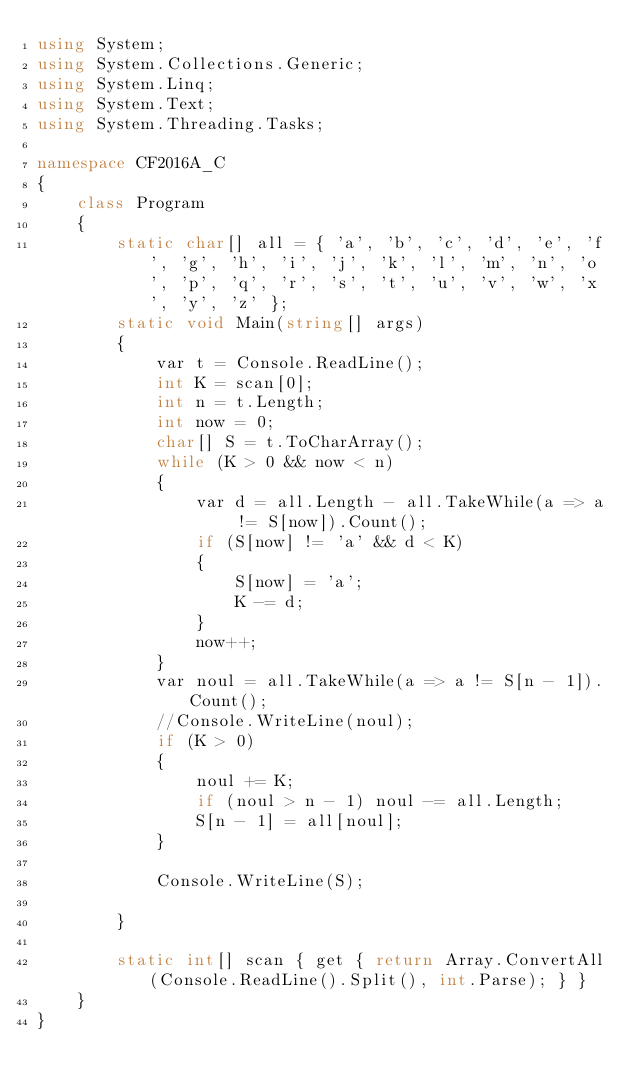<code> <loc_0><loc_0><loc_500><loc_500><_C#_>using System;
using System.Collections.Generic;
using System.Linq;
using System.Text;
using System.Threading.Tasks;

namespace CF2016A_C
{
    class Program
    {
        static char[] all = { 'a', 'b', 'c', 'd', 'e', 'f', 'g', 'h', 'i', 'j', 'k', 'l', 'm', 'n', 'o', 'p', 'q', 'r', 's', 't', 'u', 'v', 'w', 'x', 'y', 'z' };
        static void Main(string[] args)
        {
            var t = Console.ReadLine();
            int K = scan[0];
            int n = t.Length;
            int now = 0;
            char[] S = t.ToCharArray();
            while (K > 0 && now < n)
            {
                var d = all.Length - all.TakeWhile(a => a != S[now]).Count();
                if (S[now] != 'a' && d < K)
                {
                    S[now] = 'a';
                    K -= d;
                }
                now++;
            }
            var noul = all.TakeWhile(a => a != S[n - 1]).Count();
            //Console.WriteLine(noul);
            if (K > 0)
            {
                noul += K;
                if (noul > n - 1) noul -= all.Length;
                S[n - 1] = all[noul];
            }

            Console.WriteLine(S);

        }

        static int[] scan { get { return Array.ConvertAll(Console.ReadLine().Split(), int.Parse); } }
    }
}
</code> 